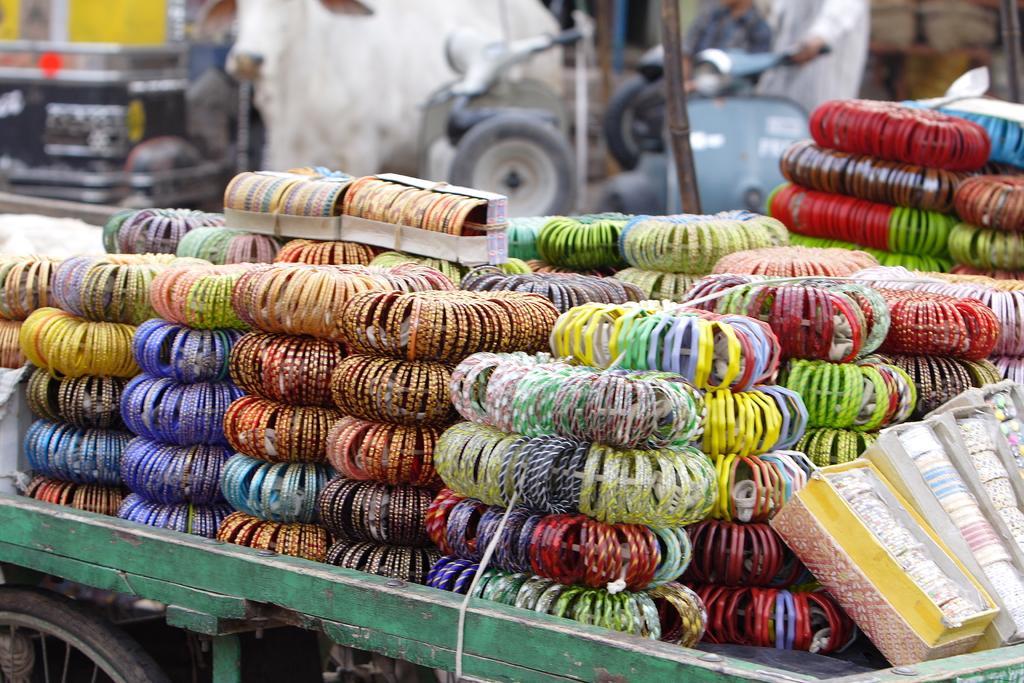Please provide a concise description of this image. In this picture we can see many bangles on a vehicle. There are few vehicles and people in the background. There are some bags on the right side. 